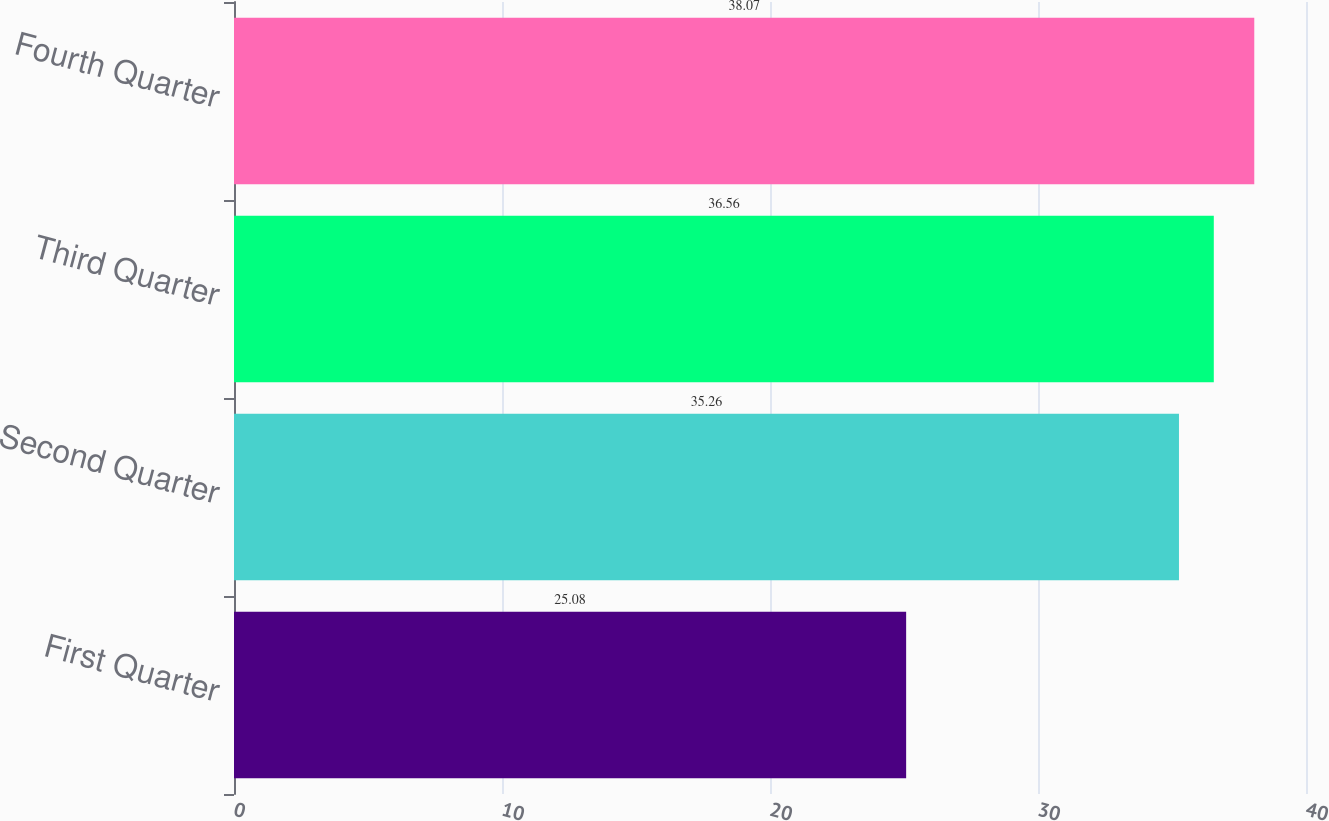Convert chart. <chart><loc_0><loc_0><loc_500><loc_500><bar_chart><fcel>First Quarter<fcel>Second Quarter<fcel>Third Quarter<fcel>Fourth Quarter<nl><fcel>25.08<fcel>35.26<fcel>36.56<fcel>38.07<nl></chart> 